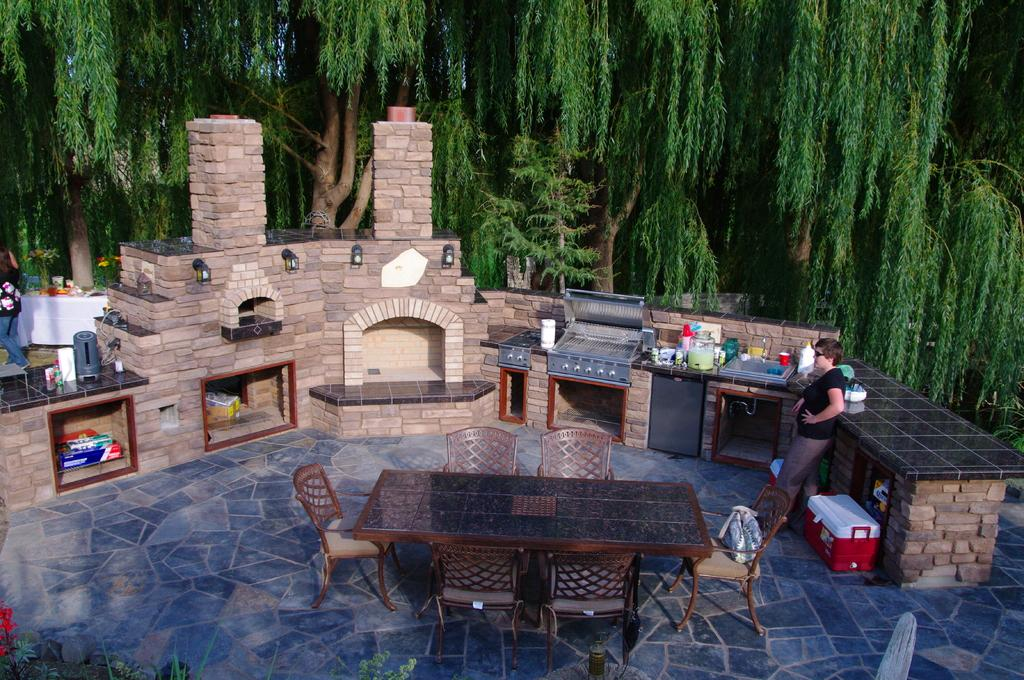Who is present in the image? There is a woman in the image. What is the woman doing in the image? The woman is standing in the image. What type of room is visible in the image? There is a kitchen in the image. What type of furniture is present in the image? There are tables and chairs in the image. What type of vegetation is present in the image? There are plants in the image. What can be seen in the background of the image? There are trees in the background of the image. What type of cherries are being used to protest in the image? There is no protest or cherries present in the image. 